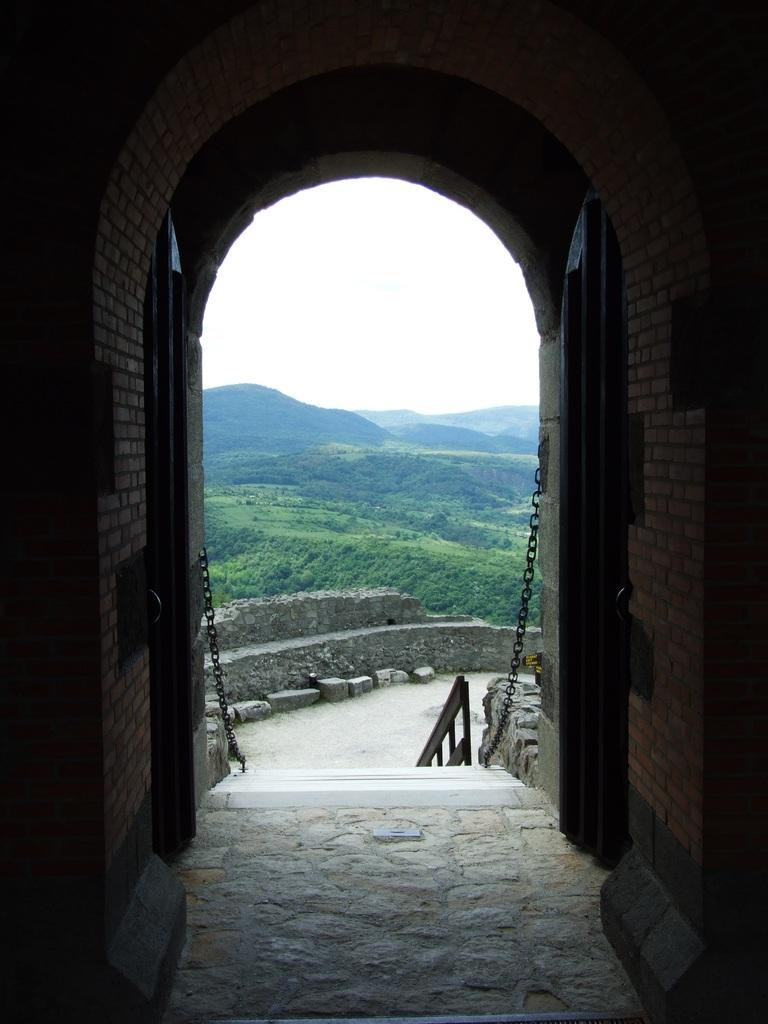What structure is visible in the image? There is a building in the image. What is in front of the building? There is a chain in front of the building. What can be seen in the background of the image? There are rocks and mountains in the background of the image. What is the color of the sky in the image? The sky is white in the image. Can you tell me how many donkeys are standing next to the building in the image? There are no donkeys present in the image. What is the name of the daughter of the person who owns the building in the image? There is no information about the owner of the building or their daughter in the image. 